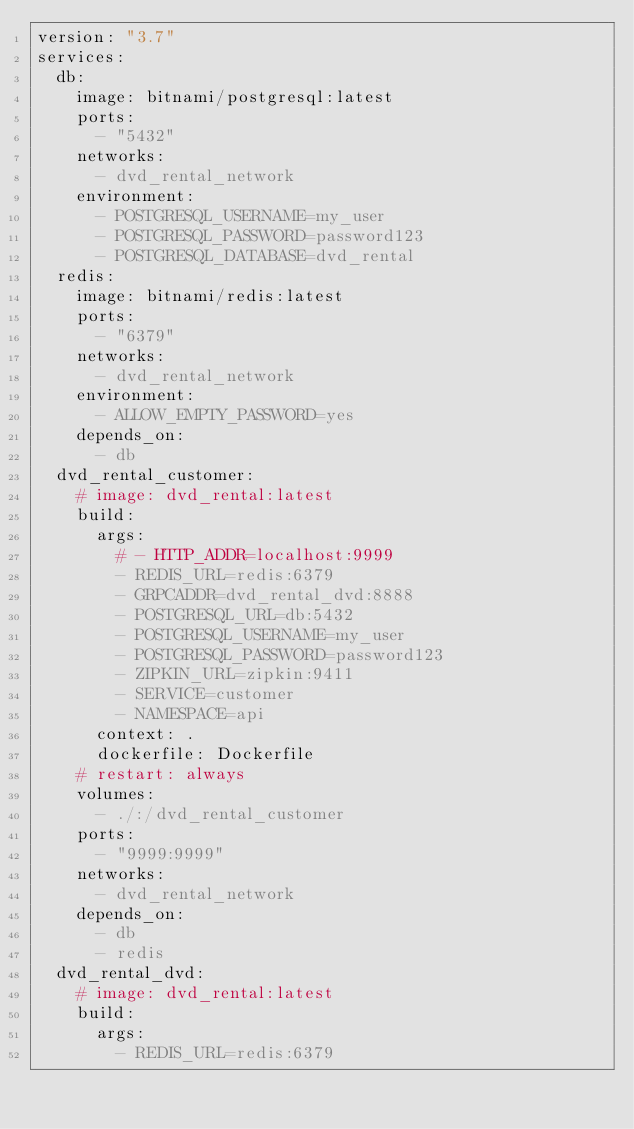Convert code to text. <code><loc_0><loc_0><loc_500><loc_500><_YAML_>version: "3.7"
services: 
  db:
    image: bitnami/postgresql:latest
    ports: 
      - "5432"
    networks: 
      - dvd_rental_network
    environment:
      - POSTGRESQL_USERNAME=my_user
      - POSTGRESQL_PASSWORD=password123
      - POSTGRESQL_DATABASE=dvd_rental
  redis:
    image: bitnami/redis:latest
    ports:
      - "6379"
    networks: 
      - dvd_rental_network
    environment:
      - ALLOW_EMPTY_PASSWORD=yes
    depends_on: 
      - db
  dvd_rental_customer:
    # image: dvd_rental:latest
    build: 
      args: 
        # - HTTP_ADDR=localhost:9999
        - REDIS_URL=redis:6379
        - GRPCADDR=dvd_rental_dvd:8888
        - POSTGRESQL_URL=db:5432
        - POSTGRESQL_USERNAME=my_user
        - POSTGRESQL_PASSWORD=password123
        - ZIPKIN_URL=zipkin:9411
        - SERVICE=customer
        - NAMESPACE=api
      context: .
      dockerfile: Dockerfile
    # restart: always
    volumes: 
      - ./:/dvd_rental_customer
    ports: 
      - "9999:9999"
    networks: 
      - dvd_rental_network
    depends_on: 
      - db
      - redis
  dvd_rental_dvd:
    # image: dvd_rental:latest
    build: 
      args: 
        - REDIS_URL=redis:6379</code> 